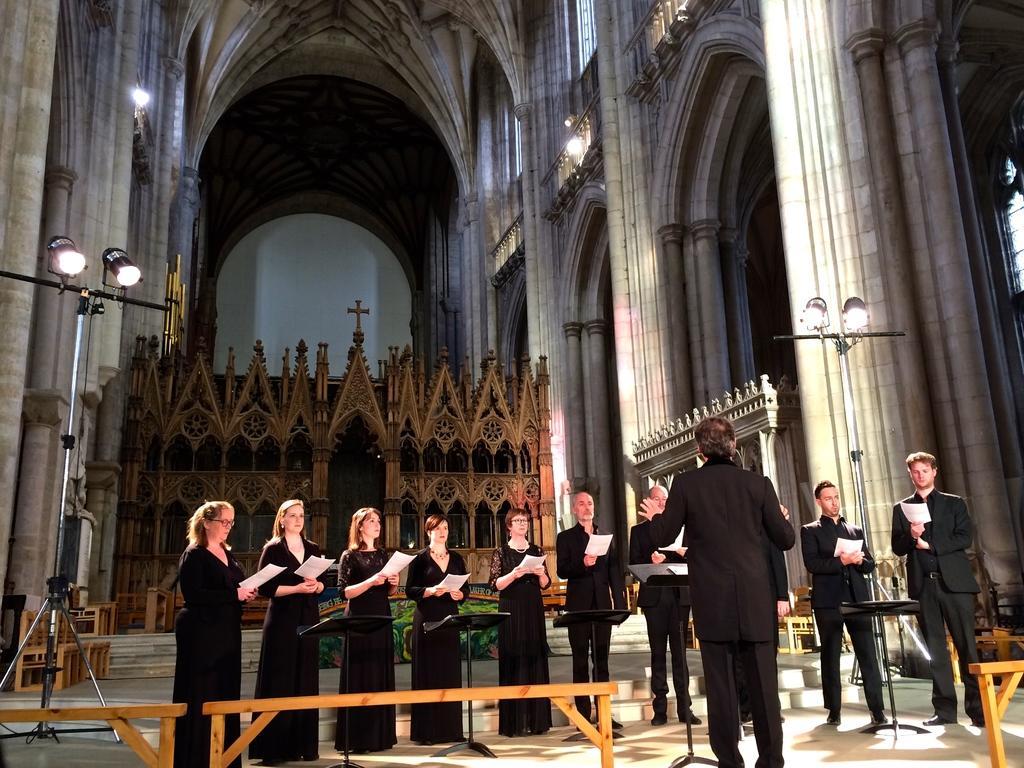How would you summarize this image in a sentence or two? In this image there are some persons standing in the bottom of this image is wearing black color dress and holding some papers. There is a light stand on the left side of this image and there is a wall in the background. 